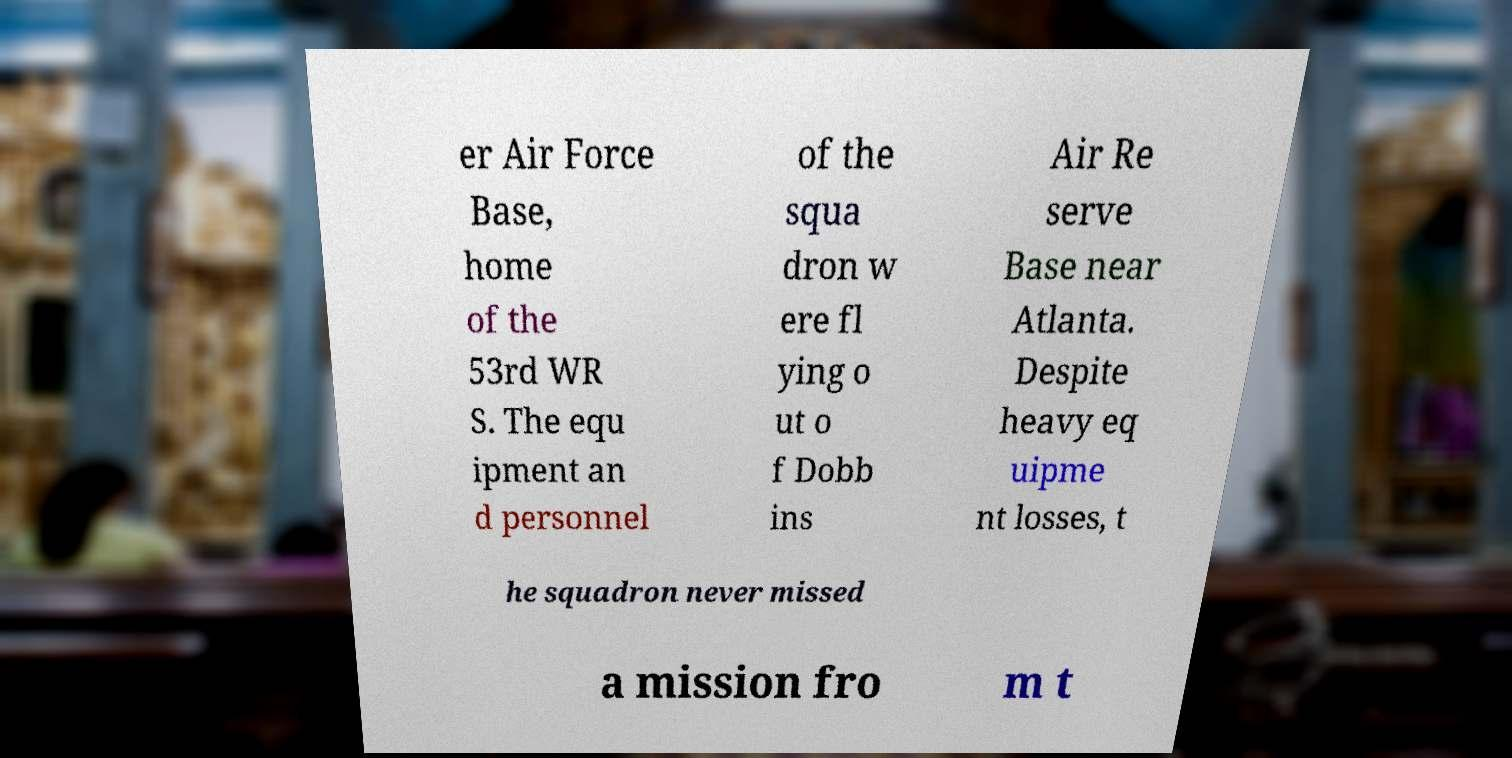I need the written content from this picture converted into text. Can you do that? er Air Force Base, home of the 53rd WR S. The equ ipment an d personnel of the squa dron w ere fl ying o ut o f Dobb ins Air Re serve Base near Atlanta. Despite heavy eq uipme nt losses, t he squadron never missed a mission fro m t 